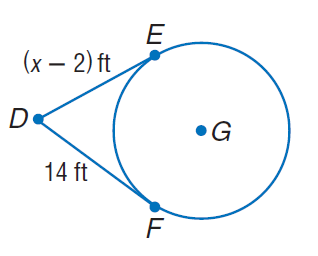Question: Find x. Assume that segments that appear to be tangent are tangent.
Choices:
A. 14
B. 15
C. 16
D. 17
Answer with the letter. Answer: C 